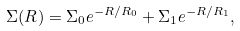<formula> <loc_0><loc_0><loc_500><loc_500>\Sigma ( R ) = \Sigma _ { 0 } e ^ { - R / R _ { 0 } } + \Sigma _ { 1 } e ^ { - R / R _ { 1 } } ,</formula> 